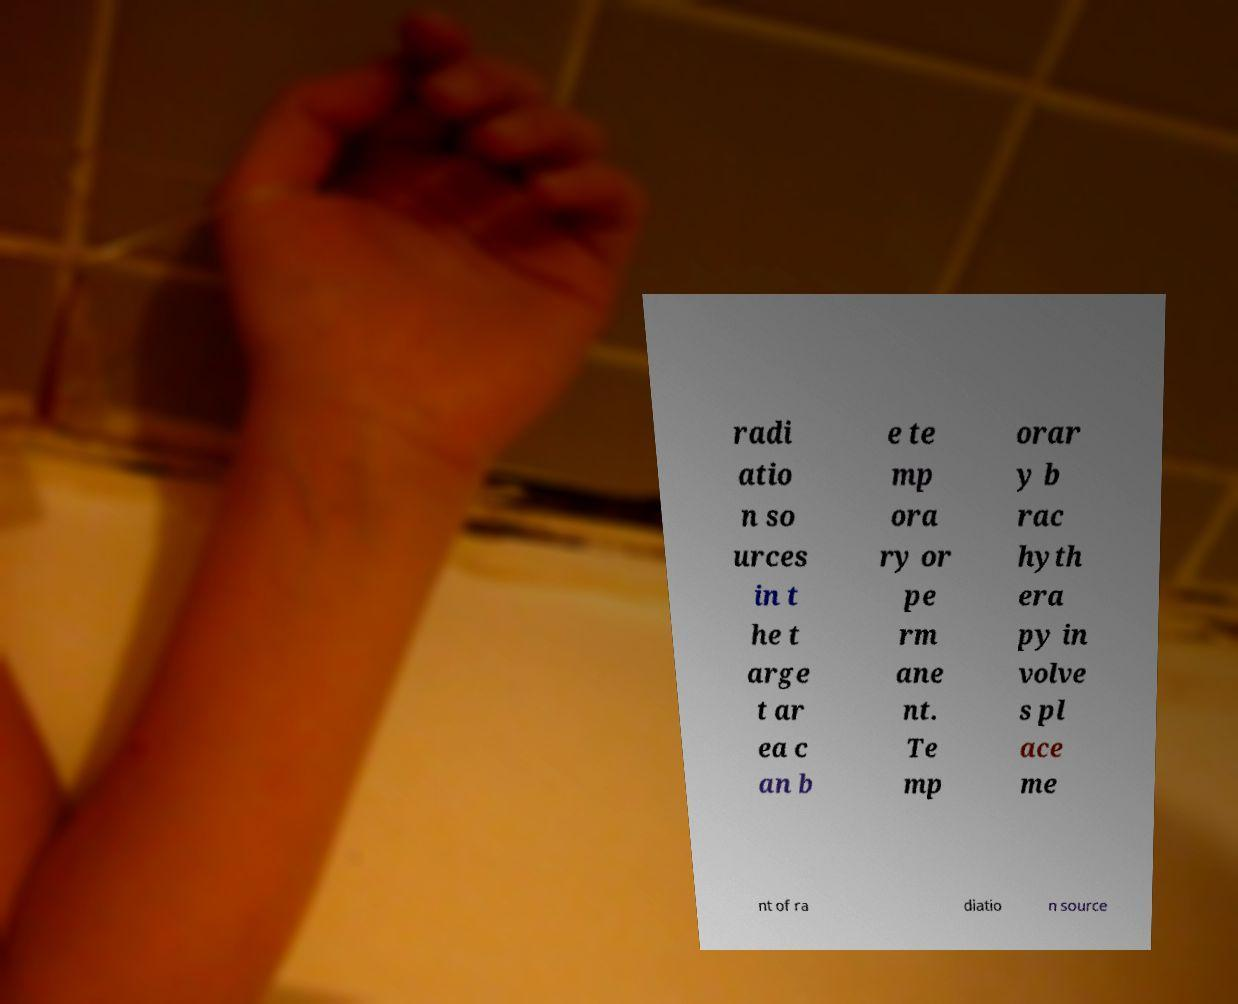I need the written content from this picture converted into text. Can you do that? radi atio n so urces in t he t arge t ar ea c an b e te mp ora ry or pe rm ane nt. Te mp orar y b rac hyth era py in volve s pl ace me nt of ra diatio n source 